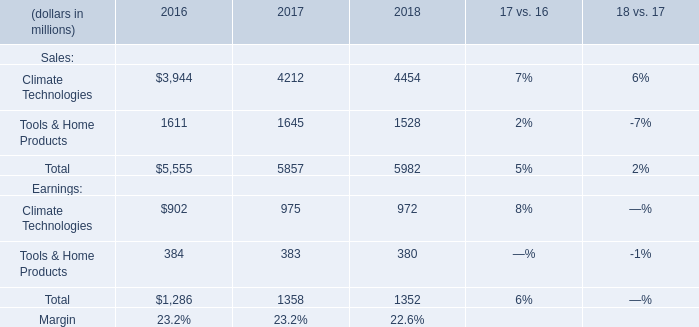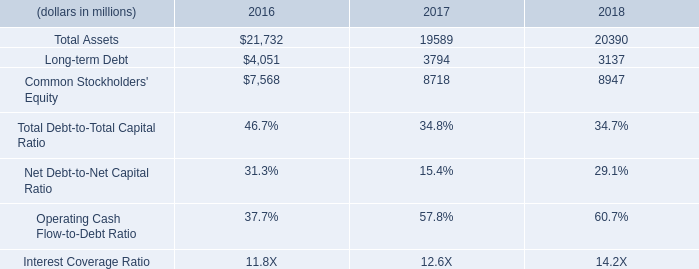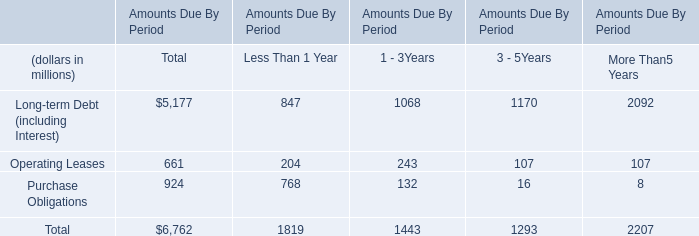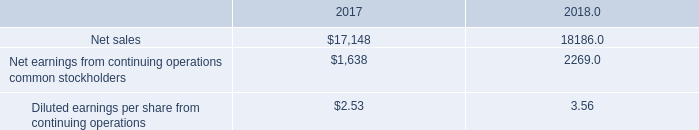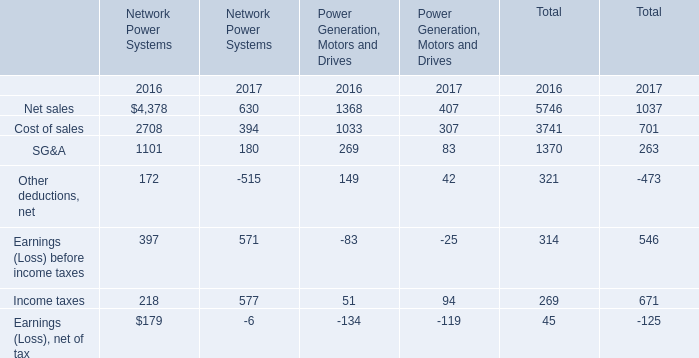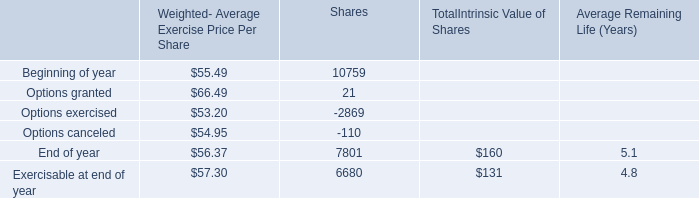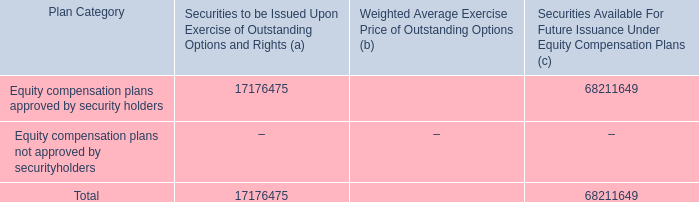What was the average value of the Net sales in the years where Net earnings from continuing operations common stockholders is positive? 
Computations: ((17148 + 18186) / 2)
Answer: 17667.0. 